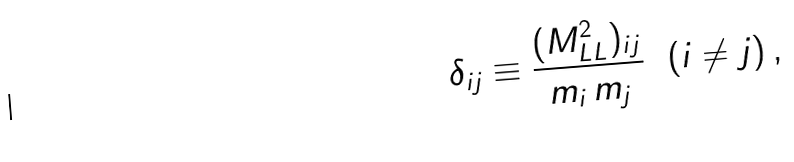<formula> <loc_0><loc_0><loc_500><loc_500>\delta _ { i j } \equiv \frac { ( M _ { L L } ^ { 2 } ) _ { i j } } { m _ { i } \, m _ { j } } \ \ ( i \neq j ) \, ,</formula> 